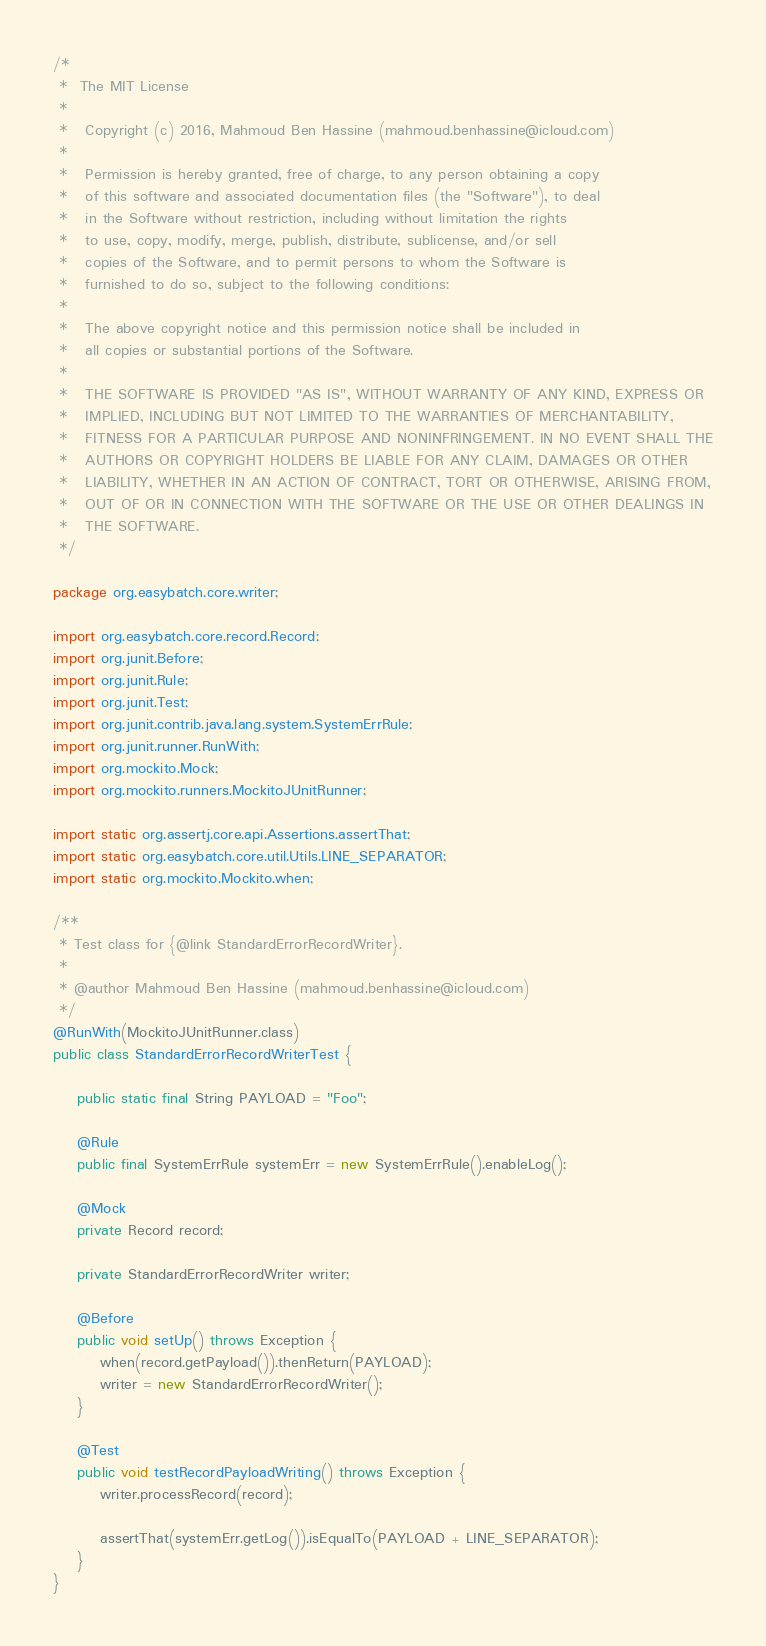<code> <loc_0><loc_0><loc_500><loc_500><_Java_>/*
 *  The MIT License
 *
 *   Copyright (c) 2016, Mahmoud Ben Hassine (mahmoud.benhassine@icloud.com)
 *
 *   Permission is hereby granted, free of charge, to any person obtaining a copy
 *   of this software and associated documentation files (the "Software"), to deal
 *   in the Software without restriction, including without limitation the rights
 *   to use, copy, modify, merge, publish, distribute, sublicense, and/or sell
 *   copies of the Software, and to permit persons to whom the Software is
 *   furnished to do so, subject to the following conditions:
 *
 *   The above copyright notice and this permission notice shall be included in
 *   all copies or substantial portions of the Software.
 *
 *   THE SOFTWARE IS PROVIDED "AS IS", WITHOUT WARRANTY OF ANY KIND, EXPRESS OR
 *   IMPLIED, INCLUDING BUT NOT LIMITED TO THE WARRANTIES OF MERCHANTABILITY,
 *   FITNESS FOR A PARTICULAR PURPOSE AND NONINFRINGEMENT. IN NO EVENT SHALL THE
 *   AUTHORS OR COPYRIGHT HOLDERS BE LIABLE FOR ANY CLAIM, DAMAGES OR OTHER
 *   LIABILITY, WHETHER IN AN ACTION OF CONTRACT, TORT OR OTHERWISE, ARISING FROM,
 *   OUT OF OR IN CONNECTION WITH THE SOFTWARE OR THE USE OR OTHER DEALINGS IN
 *   THE SOFTWARE.
 */

package org.easybatch.core.writer;

import org.easybatch.core.record.Record;
import org.junit.Before;
import org.junit.Rule;
import org.junit.Test;
import org.junit.contrib.java.lang.system.SystemErrRule;
import org.junit.runner.RunWith;
import org.mockito.Mock;
import org.mockito.runners.MockitoJUnitRunner;

import static org.assertj.core.api.Assertions.assertThat;
import static org.easybatch.core.util.Utils.LINE_SEPARATOR;
import static org.mockito.Mockito.when;

/**
 * Test class for {@link StandardErrorRecordWriter}.
 *
 * @author Mahmoud Ben Hassine (mahmoud.benhassine@icloud.com)
 */
@RunWith(MockitoJUnitRunner.class)
public class StandardErrorRecordWriterTest {

    public static final String PAYLOAD = "Foo";

    @Rule
    public final SystemErrRule systemErr = new SystemErrRule().enableLog();

    @Mock
    private Record record;

    private StandardErrorRecordWriter writer;

    @Before
    public void setUp() throws Exception {
        when(record.getPayload()).thenReturn(PAYLOAD);
        writer = new StandardErrorRecordWriter();
    }

    @Test
    public void testRecordPayloadWriting() throws Exception {
        writer.processRecord(record);

        assertThat(systemErr.getLog()).isEqualTo(PAYLOAD + LINE_SEPARATOR);
    }
}
</code> 